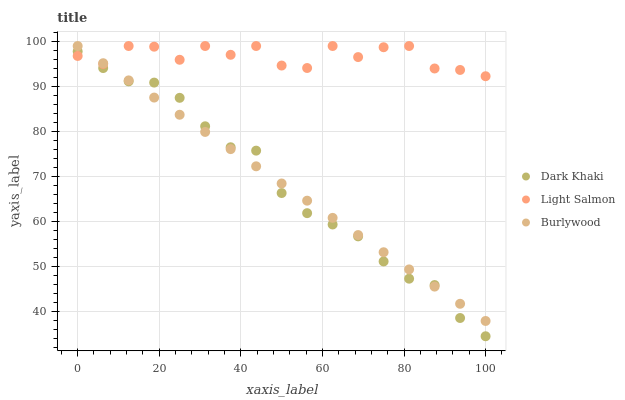Does Dark Khaki have the minimum area under the curve?
Answer yes or no. Yes. Does Light Salmon have the maximum area under the curve?
Answer yes or no. Yes. Does Burlywood have the minimum area under the curve?
Answer yes or no. No. Does Burlywood have the maximum area under the curve?
Answer yes or no. No. Is Burlywood the smoothest?
Answer yes or no. Yes. Is Light Salmon the roughest?
Answer yes or no. Yes. Is Light Salmon the smoothest?
Answer yes or no. No. Is Burlywood the roughest?
Answer yes or no. No. Does Dark Khaki have the lowest value?
Answer yes or no. Yes. Does Burlywood have the lowest value?
Answer yes or no. No. Does Light Salmon have the highest value?
Answer yes or no. Yes. Does Dark Khaki intersect Light Salmon?
Answer yes or no. Yes. Is Dark Khaki less than Light Salmon?
Answer yes or no. No. Is Dark Khaki greater than Light Salmon?
Answer yes or no. No. 